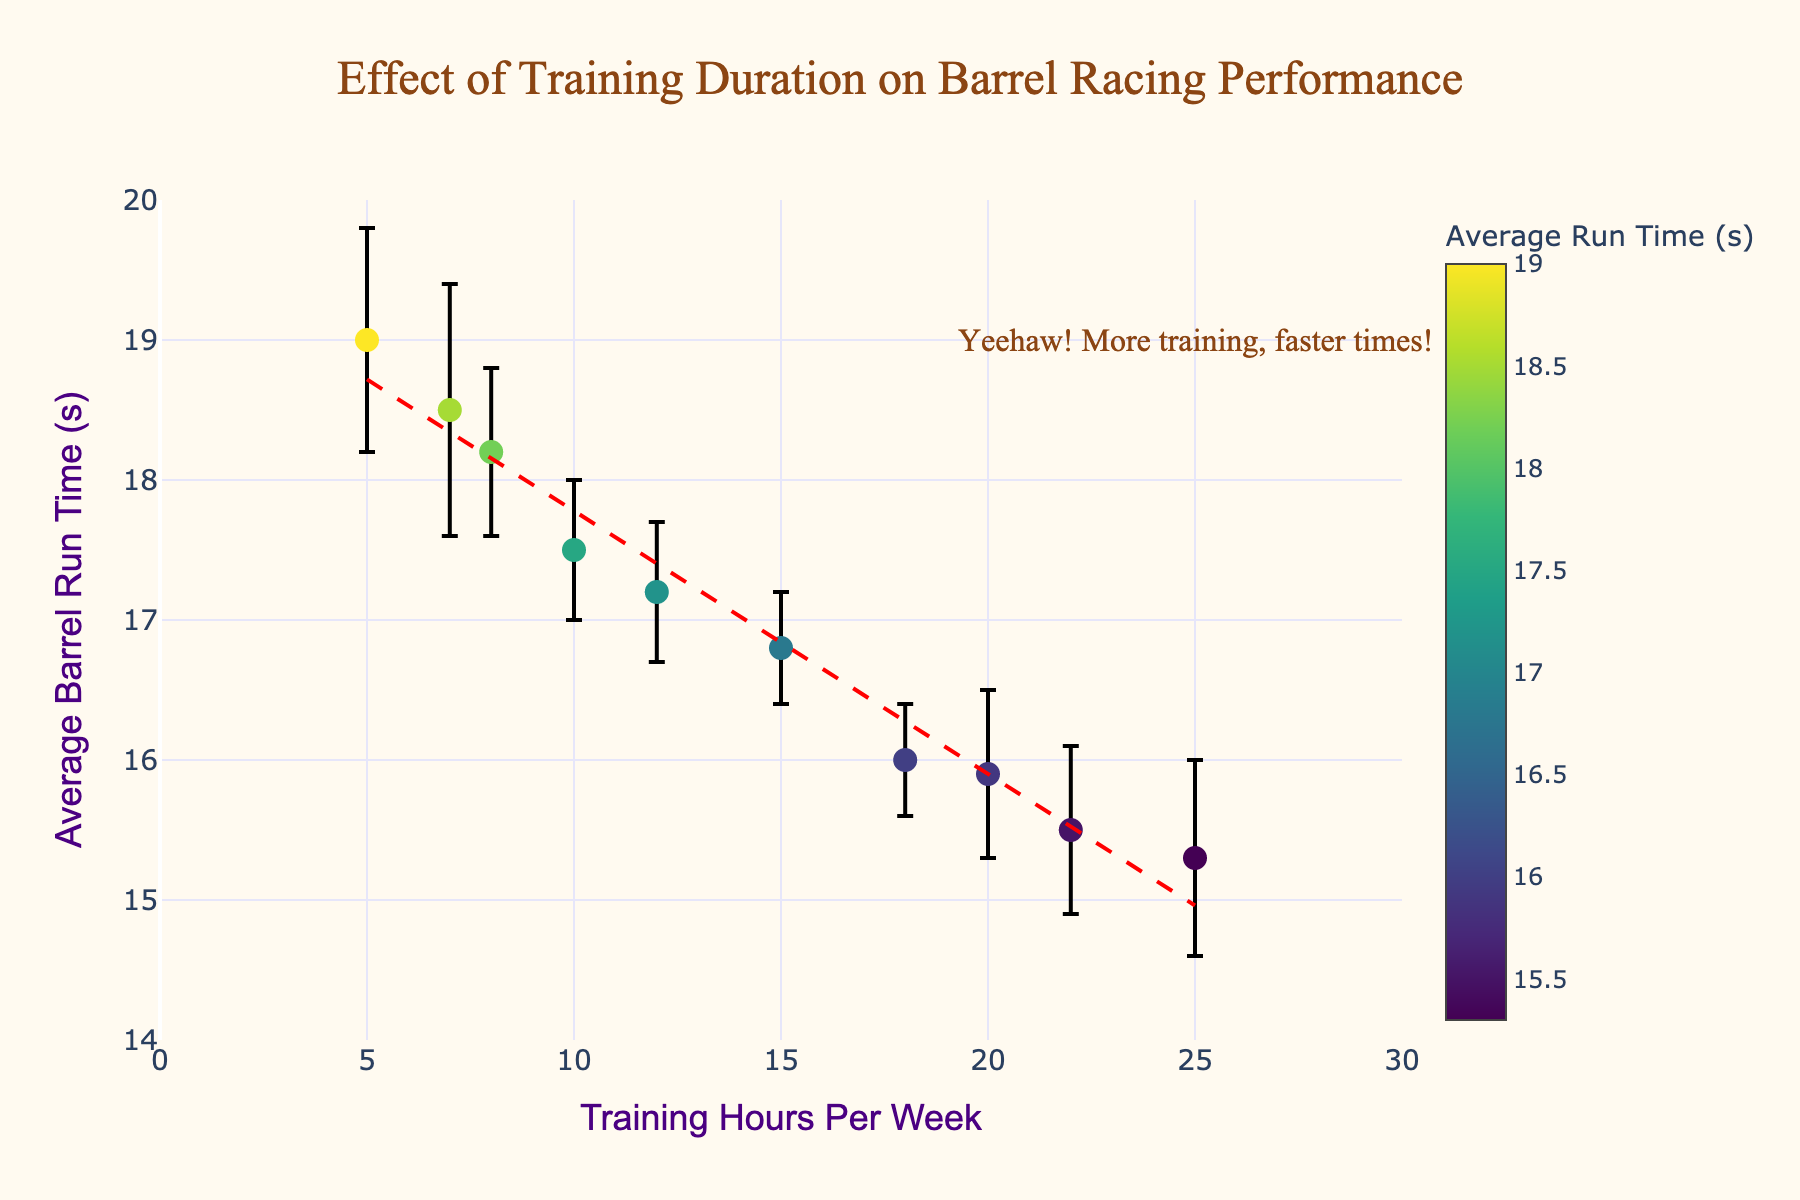How many data points are displayed in the figure? There are 10 riders listed in the dataset provided, and each rider represents a single data point in the figure. So, the number of data points displayed is 10.
Answer: 10 What is the title of the figure? The title is displayed at the top of the figure and it reads 'Effect of Training Duration on Barrel Racing Performance'.
Answer: Effect of Training Duration on Barrel Racing Performance Which rider has the lowest average barrel run time? By examining the y-axis values and the data points, RiderD has the lowest average barrel run time of 15.3 seconds.
Answer: RiderD What are the axis labels on the figure? The axis labels can be seen on the x-axis and y-axis of the figure. The x-axis is labeled 'Training Hours Per Week' and the y-axis is labeled 'Average Barrel Run Time (s)'.
Answer: Training Hours Per Week; Average Barrel Run Time (s) How does the average barrel run time generally change with increasing training hours per week based on the trendline? The trendline shows a downward slope as the training hours per week increase, indicating that the average barrel run time generally decreases with increased training.
Answer: Decreases Which rider has the highest variability in barrel run time? The variability in barrel run time can be assessed by the length of the error bars. RiderJ has the highest standard deviation of 0.9 seconds, indicating the highest variability.
Answer: RiderJ How many riders train 15 or more hours per week? By identifying the data points with 'Training Hours Per Week' of 15 or more, we have RiderB, RiderC, RiderD, RiderH, and RiderI, which total 5 riders.
Answer: 5 Compare the average barrel run times of RiderF and RiderG. RiderF has an average barrel run time of 18.2 seconds, while RiderG has an average run time of 17.2 seconds. Thus, RiderG has a faster average run time.
Answer: RiderG What is the range of standard deviations for the barrel run times in the figure? From the provided data, the standard deviations range from 0.4 seconds to 0.9 seconds.
Answer: 0.4 to 0.9 seconds What inference can be made about the relationship between training hours and performance in barrel racing from the annotations on the figure? The annotation "Yeehaw! More training, faster times!" suggests that increased training hours correlate with improved (faster) barrel racing performance.
Answer: Increased training correlates with faster times 